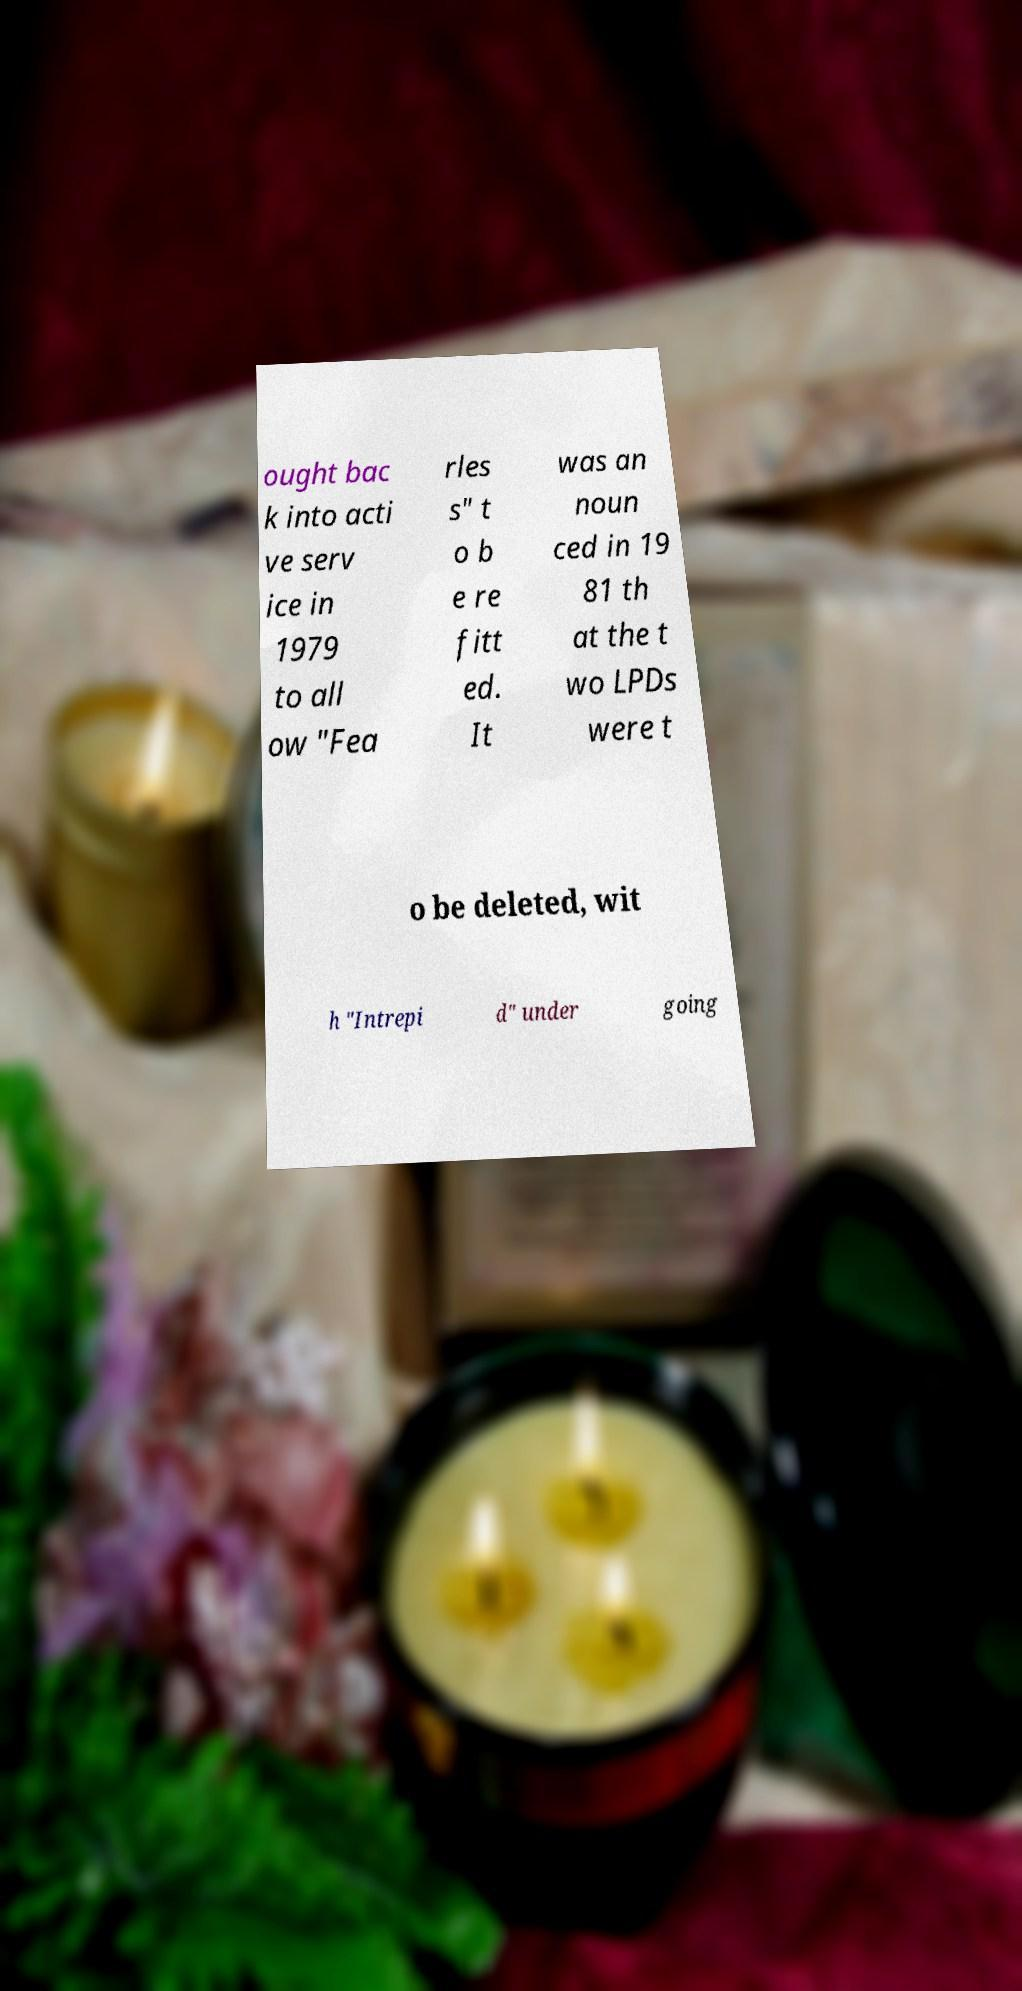What messages or text are displayed in this image? I need them in a readable, typed format. ought bac k into acti ve serv ice in 1979 to all ow "Fea rles s" t o b e re fitt ed. It was an noun ced in 19 81 th at the t wo LPDs were t o be deleted, wit h "Intrepi d" under going 